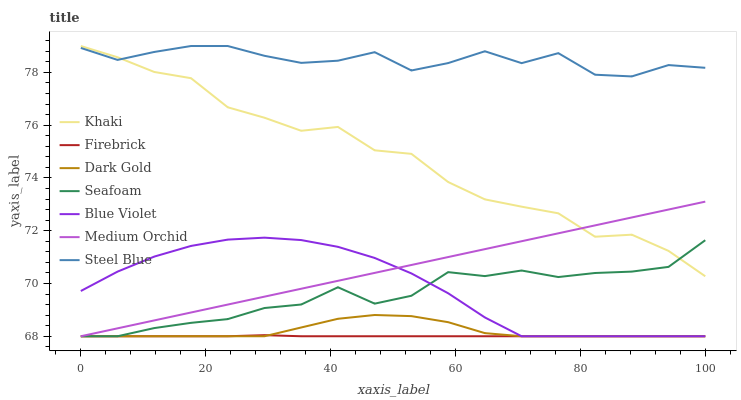Does Dark Gold have the minimum area under the curve?
Answer yes or no. No. Does Dark Gold have the maximum area under the curve?
Answer yes or no. No. Is Dark Gold the smoothest?
Answer yes or no. No. Is Dark Gold the roughest?
Answer yes or no. No. Does Steel Blue have the lowest value?
Answer yes or no. No. Does Dark Gold have the highest value?
Answer yes or no. No. Is Blue Violet less than Steel Blue?
Answer yes or no. Yes. Is Khaki greater than Blue Violet?
Answer yes or no. Yes. Does Blue Violet intersect Steel Blue?
Answer yes or no. No. 